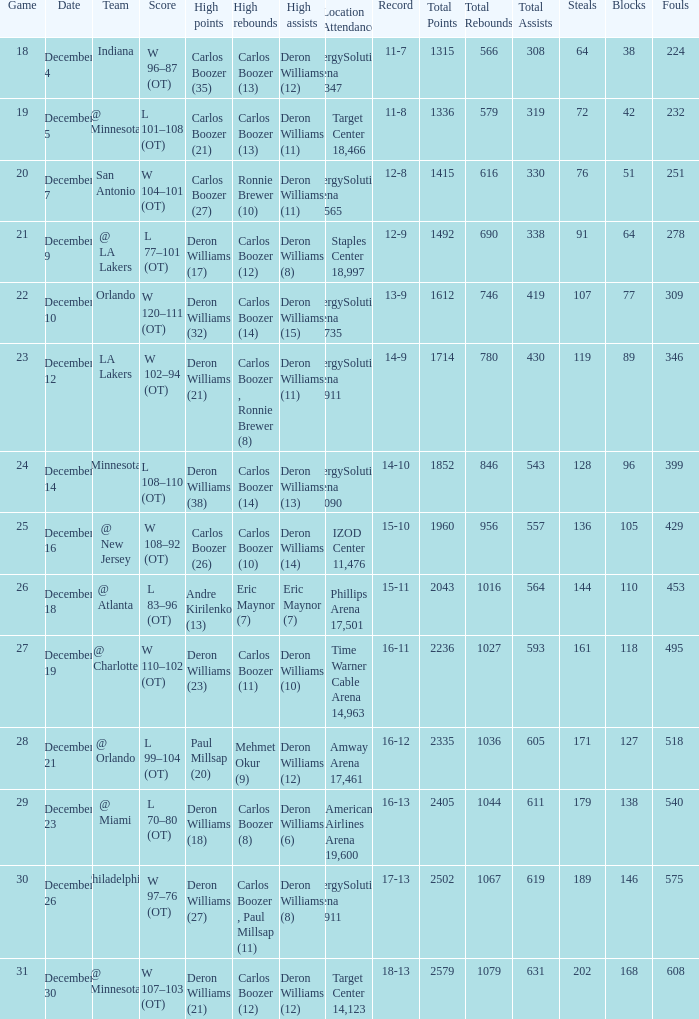How many different high rebound results are there for the game number 26? 1.0. 